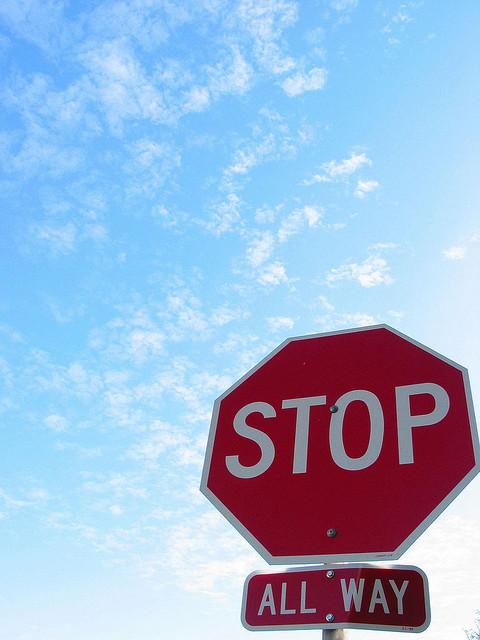What color is the sign?
Be succinct. Red. What color are the clouds in this photo?
Keep it brief. White. What does it say under the stop sign?
Keep it brief. All way. What is in the sky?
Answer briefly. Clouds. Where is the graffiti?
Keep it brief. None. What street name is displayed on the sign?
Short answer required. None. What does the sign with the red circle mean?
Concise answer only. Stop. What does the sign under the stop say?
Write a very short answer. All way. What would you call the writing under the word 'STOP'?
Give a very brief answer. All way. Are there trees visible?
Give a very brief answer. No. 